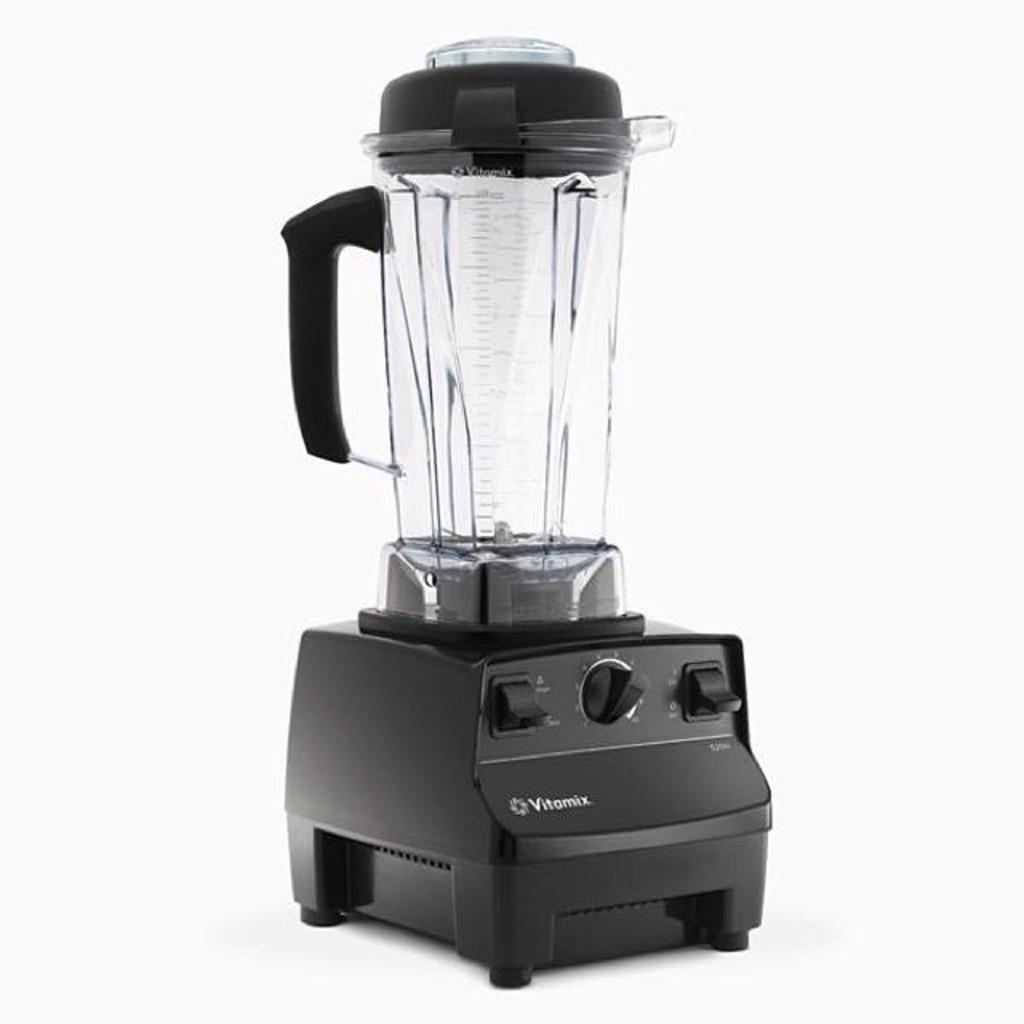What is the brand of this blender?
Keep it short and to the point. Vitamix. Whats the name of the blender?
Provide a succinct answer. Vitamix. 